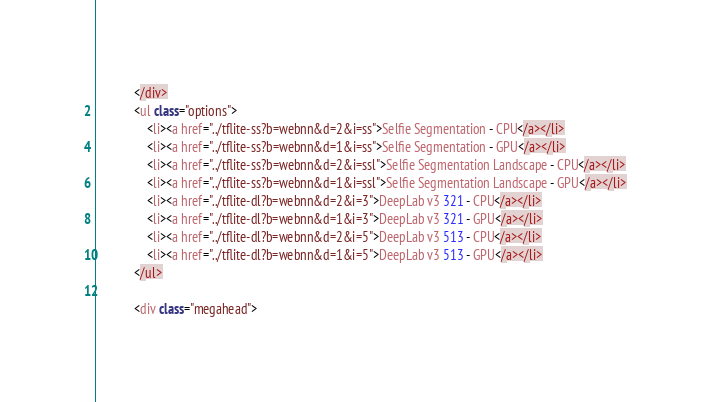Convert code to text. <code><loc_0><loc_0><loc_500><loc_500><_JavaScript_>            </div>
            <ul class="options">
                <li><a href="../tflite-ss?b=webnn&d=2&i=ss">Selfie Segmentation - CPU</a></li>
                <li><a href="../tflite-ss?b=webnn&d=1&i=ss">Selfie Segmentation - GPU</a></li>
                <li><a href="../tflite-ss?b=webnn&d=2&i=ssl">Selfie Segmentation Landscape - CPU</a></li>
                <li><a href="../tflite-ss?b=webnn&d=1&i=ssl">Selfie Segmentation Landscape - GPU</a></li>
                <li><a href="../tflite-dl?b=webnn&d=2&i=3">DeepLab v3 321 - CPU</a></li>
                <li><a href="../tflite-dl?b=webnn&d=1&i=3">DeepLab v3 321 - GPU</a></li>
                <li><a href="../tflite-dl?b=webnn&d=2&i=5">DeepLab v3 513 - CPU</a></li>
                <li><a href="../tflite-dl?b=webnn&d=1&i=5">DeepLab v3 513 - GPU</a></li>
            </ul>

            <div class="megahead"></code> 